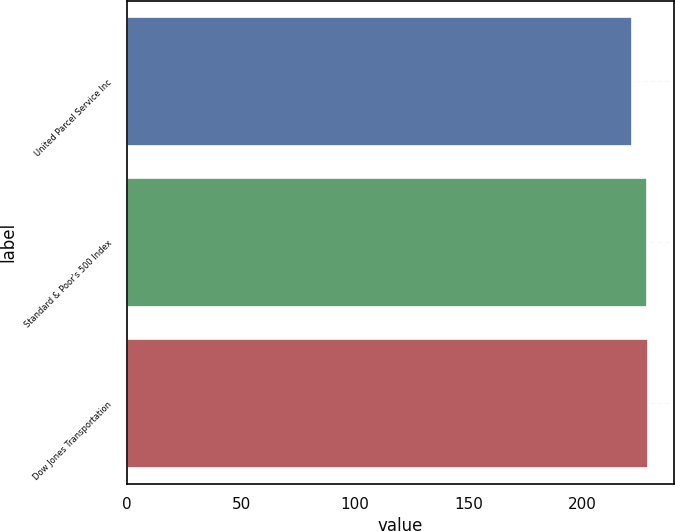Convert chart. <chart><loc_0><loc_0><loc_500><loc_500><bar_chart><fcel>United Parcel Service Inc<fcel>Standard & Poor's 500 Index<fcel>Dow Jones Transportation<nl><fcel>221.91<fcel>228.09<fcel>228.74<nl></chart> 